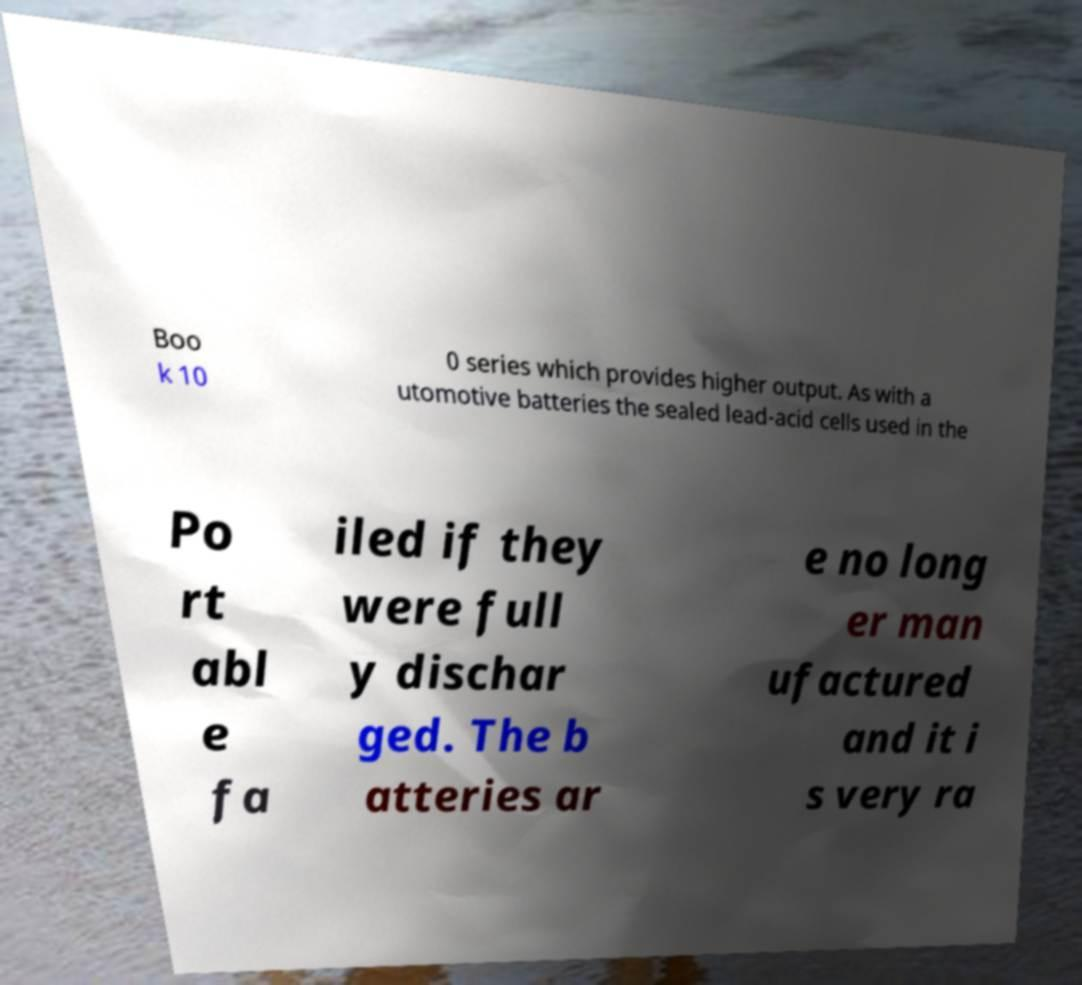Can you read and provide the text displayed in the image?This photo seems to have some interesting text. Can you extract and type it out for me? Boo k 10 0 series which provides higher output. As with a utomotive batteries the sealed lead-acid cells used in the Po rt abl e fa iled if they were full y dischar ged. The b atteries ar e no long er man ufactured and it i s very ra 